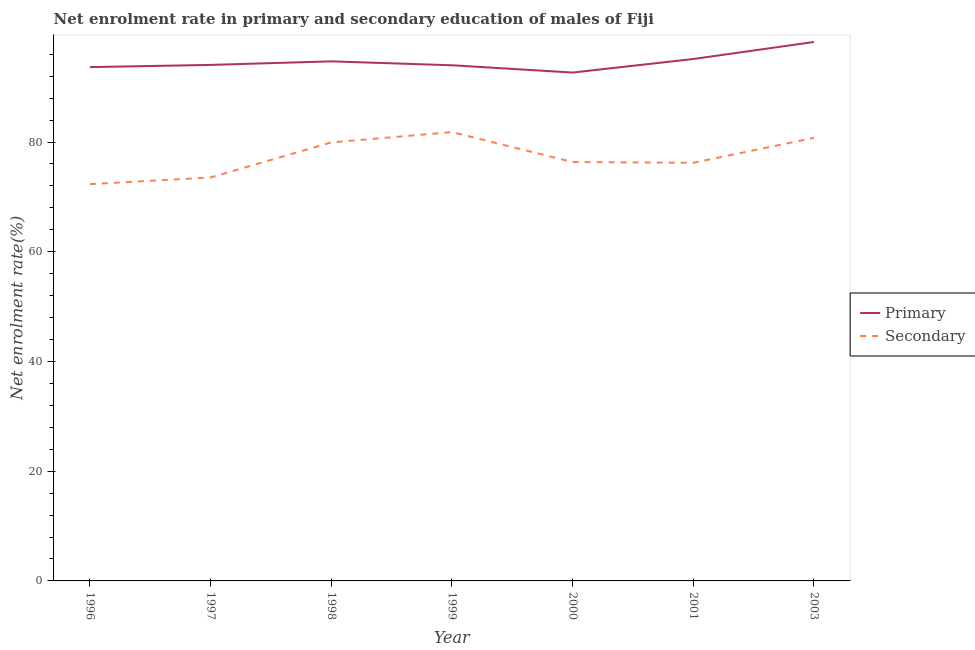Is the number of lines equal to the number of legend labels?
Keep it short and to the point. Yes. What is the enrollment rate in primary education in 2000?
Keep it short and to the point. 92.66. Across all years, what is the maximum enrollment rate in primary education?
Give a very brief answer. 98.23. Across all years, what is the minimum enrollment rate in secondary education?
Ensure brevity in your answer.  72.32. In which year was the enrollment rate in primary education maximum?
Give a very brief answer. 2003. What is the total enrollment rate in primary education in the graph?
Your response must be concise. 662.42. What is the difference between the enrollment rate in primary education in 1999 and that in 2000?
Keep it short and to the point. 1.33. What is the difference between the enrollment rate in secondary education in 1999 and the enrollment rate in primary education in 1996?
Keep it short and to the point. -11.85. What is the average enrollment rate in secondary education per year?
Ensure brevity in your answer.  77.27. In the year 1998, what is the difference between the enrollment rate in secondary education and enrollment rate in primary education?
Give a very brief answer. -14.77. In how many years, is the enrollment rate in secondary education greater than 52 %?
Give a very brief answer. 7. What is the ratio of the enrollment rate in secondary education in 1996 to that in 1999?
Your answer should be compact. 0.88. What is the difference between the highest and the second highest enrollment rate in secondary education?
Your response must be concise. 1.04. What is the difference between the highest and the lowest enrollment rate in primary education?
Offer a very short reply. 5.57. In how many years, is the enrollment rate in secondary education greater than the average enrollment rate in secondary education taken over all years?
Provide a short and direct response. 3. Is the enrollment rate in primary education strictly less than the enrollment rate in secondary education over the years?
Ensure brevity in your answer.  No. How many lines are there?
Offer a terse response. 2. Does the graph contain any zero values?
Ensure brevity in your answer.  No. Does the graph contain grids?
Keep it short and to the point. No. How many legend labels are there?
Your response must be concise. 2. What is the title of the graph?
Your answer should be very brief. Net enrolment rate in primary and secondary education of males of Fiji. What is the label or title of the X-axis?
Provide a succinct answer. Year. What is the label or title of the Y-axis?
Provide a short and direct response. Net enrolment rate(%). What is the Net enrolment rate(%) in Primary in 1996?
Offer a very short reply. 93.65. What is the Net enrolment rate(%) in Secondary in 1996?
Offer a terse response. 72.32. What is the Net enrolment rate(%) in Primary in 1997?
Your response must be concise. 94.05. What is the Net enrolment rate(%) of Secondary in 1997?
Give a very brief answer. 73.54. What is the Net enrolment rate(%) in Primary in 1998?
Your answer should be very brief. 94.7. What is the Net enrolment rate(%) of Secondary in 1998?
Provide a short and direct response. 79.93. What is the Net enrolment rate(%) of Primary in 1999?
Provide a succinct answer. 93.99. What is the Net enrolment rate(%) of Secondary in 1999?
Provide a succinct answer. 81.81. What is the Net enrolment rate(%) in Primary in 2000?
Your answer should be compact. 92.66. What is the Net enrolment rate(%) in Secondary in 2000?
Your answer should be very brief. 76.35. What is the Net enrolment rate(%) of Primary in 2001?
Offer a terse response. 95.13. What is the Net enrolment rate(%) in Secondary in 2001?
Your answer should be compact. 76.21. What is the Net enrolment rate(%) of Primary in 2003?
Give a very brief answer. 98.23. What is the Net enrolment rate(%) in Secondary in 2003?
Make the answer very short. 80.76. Across all years, what is the maximum Net enrolment rate(%) of Primary?
Your response must be concise. 98.23. Across all years, what is the maximum Net enrolment rate(%) of Secondary?
Offer a terse response. 81.81. Across all years, what is the minimum Net enrolment rate(%) of Primary?
Your answer should be very brief. 92.66. Across all years, what is the minimum Net enrolment rate(%) in Secondary?
Your response must be concise. 72.32. What is the total Net enrolment rate(%) in Primary in the graph?
Provide a short and direct response. 662.42. What is the total Net enrolment rate(%) in Secondary in the graph?
Ensure brevity in your answer.  540.92. What is the difference between the Net enrolment rate(%) of Primary in 1996 and that in 1997?
Provide a short and direct response. -0.4. What is the difference between the Net enrolment rate(%) of Secondary in 1996 and that in 1997?
Your answer should be compact. -1.21. What is the difference between the Net enrolment rate(%) of Primary in 1996 and that in 1998?
Your answer should be very brief. -1.05. What is the difference between the Net enrolment rate(%) in Secondary in 1996 and that in 1998?
Ensure brevity in your answer.  -7.61. What is the difference between the Net enrolment rate(%) of Primary in 1996 and that in 1999?
Your answer should be very brief. -0.34. What is the difference between the Net enrolment rate(%) in Secondary in 1996 and that in 1999?
Offer a very short reply. -9.49. What is the difference between the Net enrolment rate(%) in Primary in 1996 and that in 2000?
Provide a succinct answer. 0.99. What is the difference between the Net enrolment rate(%) of Secondary in 1996 and that in 2000?
Offer a terse response. -4.03. What is the difference between the Net enrolment rate(%) of Primary in 1996 and that in 2001?
Offer a terse response. -1.48. What is the difference between the Net enrolment rate(%) in Secondary in 1996 and that in 2001?
Provide a short and direct response. -3.89. What is the difference between the Net enrolment rate(%) in Primary in 1996 and that in 2003?
Ensure brevity in your answer.  -4.58. What is the difference between the Net enrolment rate(%) in Secondary in 1996 and that in 2003?
Your answer should be compact. -8.44. What is the difference between the Net enrolment rate(%) in Primary in 1997 and that in 1998?
Provide a succinct answer. -0.65. What is the difference between the Net enrolment rate(%) of Secondary in 1997 and that in 1998?
Ensure brevity in your answer.  -6.4. What is the difference between the Net enrolment rate(%) in Primary in 1997 and that in 1999?
Your answer should be very brief. 0.07. What is the difference between the Net enrolment rate(%) of Secondary in 1997 and that in 1999?
Make the answer very short. -8.27. What is the difference between the Net enrolment rate(%) in Primary in 1997 and that in 2000?
Offer a terse response. 1.39. What is the difference between the Net enrolment rate(%) in Secondary in 1997 and that in 2000?
Your answer should be compact. -2.82. What is the difference between the Net enrolment rate(%) in Primary in 1997 and that in 2001?
Your response must be concise. -1.07. What is the difference between the Net enrolment rate(%) in Secondary in 1997 and that in 2001?
Provide a succinct answer. -2.67. What is the difference between the Net enrolment rate(%) of Primary in 1997 and that in 2003?
Give a very brief answer. -4.18. What is the difference between the Net enrolment rate(%) in Secondary in 1997 and that in 2003?
Give a very brief answer. -7.23. What is the difference between the Net enrolment rate(%) of Primary in 1998 and that in 1999?
Your answer should be very brief. 0.71. What is the difference between the Net enrolment rate(%) of Secondary in 1998 and that in 1999?
Ensure brevity in your answer.  -1.87. What is the difference between the Net enrolment rate(%) of Primary in 1998 and that in 2000?
Provide a short and direct response. 2.04. What is the difference between the Net enrolment rate(%) of Secondary in 1998 and that in 2000?
Provide a succinct answer. 3.58. What is the difference between the Net enrolment rate(%) in Primary in 1998 and that in 2001?
Provide a succinct answer. -0.43. What is the difference between the Net enrolment rate(%) of Secondary in 1998 and that in 2001?
Your answer should be compact. 3.72. What is the difference between the Net enrolment rate(%) in Primary in 1998 and that in 2003?
Ensure brevity in your answer.  -3.53. What is the difference between the Net enrolment rate(%) of Secondary in 1998 and that in 2003?
Your answer should be compact. -0.83. What is the difference between the Net enrolment rate(%) in Primary in 1999 and that in 2000?
Keep it short and to the point. 1.33. What is the difference between the Net enrolment rate(%) in Secondary in 1999 and that in 2000?
Ensure brevity in your answer.  5.46. What is the difference between the Net enrolment rate(%) in Primary in 1999 and that in 2001?
Keep it short and to the point. -1.14. What is the difference between the Net enrolment rate(%) in Secondary in 1999 and that in 2001?
Your answer should be very brief. 5.6. What is the difference between the Net enrolment rate(%) in Primary in 1999 and that in 2003?
Your answer should be compact. -4.24. What is the difference between the Net enrolment rate(%) in Secondary in 1999 and that in 2003?
Ensure brevity in your answer.  1.04. What is the difference between the Net enrolment rate(%) in Primary in 2000 and that in 2001?
Offer a very short reply. -2.47. What is the difference between the Net enrolment rate(%) of Secondary in 2000 and that in 2001?
Ensure brevity in your answer.  0.14. What is the difference between the Net enrolment rate(%) of Primary in 2000 and that in 2003?
Your response must be concise. -5.57. What is the difference between the Net enrolment rate(%) in Secondary in 2000 and that in 2003?
Ensure brevity in your answer.  -4.41. What is the difference between the Net enrolment rate(%) of Primary in 2001 and that in 2003?
Your answer should be very brief. -3.1. What is the difference between the Net enrolment rate(%) of Secondary in 2001 and that in 2003?
Offer a terse response. -4.56. What is the difference between the Net enrolment rate(%) of Primary in 1996 and the Net enrolment rate(%) of Secondary in 1997?
Provide a short and direct response. 20.12. What is the difference between the Net enrolment rate(%) in Primary in 1996 and the Net enrolment rate(%) in Secondary in 1998?
Offer a very short reply. 13.72. What is the difference between the Net enrolment rate(%) of Primary in 1996 and the Net enrolment rate(%) of Secondary in 1999?
Offer a terse response. 11.85. What is the difference between the Net enrolment rate(%) of Primary in 1996 and the Net enrolment rate(%) of Secondary in 2000?
Offer a terse response. 17.3. What is the difference between the Net enrolment rate(%) of Primary in 1996 and the Net enrolment rate(%) of Secondary in 2001?
Ensure brevity in your answer.  17.45. What is the difference between the Net enrolment rate(%) in Primary in 1996 and the Net enrolment rate(%) in Secondary in 2003?
Keep it short and to the point. 12.89. What is the difference between the Net enrolment rate(%) in Primary in 1997 and the Net enrolment rate(%) in Secondary in 1998?
Your answer should be compact. 14.12. What is the difference between the Net enrolment rate(%) in Primary in 1997 and the Net enrolment rate(%) in Secondary in 1999?
Your response must be concise. 12.25. What is the difference between the Net enrolment rate(%) in Primary in 1997 and the Net enrolment rate(%) in Secondary in 2000?
Your answer should be very brief. 17.7. What is the difference between the Net enrolment rate(%) in Primary in 1997 and the Net enrolment rate(%) in Secondary in 2001?
Your response must be concise. 17.85. What is the difference between the Net enrolment rate(%) of Primary in 1997 and the Net enrolment rate(%) of Secondary in 2003?
Your response must be concise. 13.29. What is the difference between the Net enrolment rate(%) of Primary in 1998 and the Net enrolment rate(%) of Secondary in 1999?
Give a very brief answer. 12.89. What is the difference between the Net enrolment rate(%) in Primary in 1998 and the Net enrolment rate(%) in Secondary in 2000?
Provide a succinct answer. 18.35. What is the difference between the Net enrolment rate(%) of Primary in 1998 and the Net enrolment rate(%) of Secondary in 2001?
Provide a short and direct response. 18.49. What is the difference between the Net enrolment rate(%) in Primary in 1998 and the Net enrolment rate(%) in Secondary in 2003?
Your response must be concise. 13.94. What is the difference between the Net enrolment rate(%) of Primary in 1999 and the Net enrolment rate(%) of Secondary in 2000?
Offer a very short reply. 17.64. What is the difference between the Net enrolment rate(%) in Primary in 1999 and the Net enrolment rate(%) in Secondary in 2001?
Offer a very short reply. 17.78. What is the difference between the Net enrolment rate(%) of Primary in 1999 and the Net enrolment rate(%) of Secondary in 2003?
Keep it short and to the point. 13.22. What is the difference between the Net enrolment rate(%) of Primary in 2000 and the Net enrolment rate(%) of Secondary in 2001?
Make the answer very short. 16.45. What is the difference between the Net enrolment rate(%) of Primary in 2000 and the Net enrolment rate(%) of Secondary in 2003?
Give a very brief answer. 11.9. What is the difference between the Net enrolment rate(%) in Primary in 2001 and the Net enrolment rate(%) in Secondary in 2003?
Your response must be concise. 14.36. What is the average Net enrolment rate(%) of Primary per year?
Your answer should be compact. 94.63. What is the average Net enrolment rate(%) of Secondary per year?
Your answer should be very brief. 77.27. In the year 1996, what is the difference between the Net enrolment rate(%) of Primary and Net enrolment rate(%) of Secondary?
Your answer should be very brief. 21.33. In the year 1997, what is the difference between the Net enrolment rate(%) of Primary and Net enrolment rate(%) of Secondary?
Make the answer very short. 20.52. In the year 1998, what is the difference between the Net enrolment rate(%) of Primary and Net enrolment rate(%) of Secondary?
Provide a short and direct response. 14.77. In the year 1999, what is the difference between the Net enrolment rate(%) in Primary and Net enrolment rate(%) in Secondary?
Ensure brevity in your answer.  12.18. In the year 2000, what is the difference between the Net enrolment rate(%) in Primary and Net enrolment rate(%) in Secondary?
Your response must be concise. 16.31. In the year 2001, what is the difference between the Net enrolment rate(%) in Primary and Net enrolment rate(%) in Secondary?
Provide a succinct answer. 18.92. In the year 2003, what is the difference between the Net enrolment rate(%) in Primary and Net enrolment rate(%) in Secondary?
Your answer should be very brief. 17.47. What is the ratio of the Net enrolment rate(%) of Secondary in 1996 to that in 1997?
Keep it short and to the point. 0.98. What is the ratio of the Net enrolment rate(%) in Primary in 1996 to that in 1998?
Ensure brevity in your answer.  0.99. What is the ratio of the Net enrolment rate(%) in Secondary in 1996 to that in 1998?
Offer a very short reply. 0.9. What is the ratio of the Net enrolment rate(%) of Secondary in 1996 to that in 1999?
Offer a terse response. 0.88. What is the ratio of the Net enrolment rate(%) of Primary in 1996 to that in 2000?
Offer a very short reply. 1.01. What is the ratio of the Net enrolment rate(%) of Secondary in 1996 to that in 2000?
Provide a short and direct response. 0.95. What is the ratio of the Net enrolment rate(%) in Primary in 1996 to that in 2001?
Offer a very short reply. 0.98. What is the ratio of the Net enrolment rate(%) of Secondary in 1996 to that in 2001?
Provide a short and direct response. 0.95. What is the ratio of the Net enrolment rate(%) of Primary in 1996 to that in 2003?
Make the answer very short. 0.95. What is the ratio of the Net enrolment rate(%) of Secondary in 1996 to that in 2003?
Provide a succinct answer. 0.9. What is the ratio of the Net enrolment rate(%) in Secondary in 1997 to that in 1998?
Your answer should be very brief. 0.92. What is the ratio of the Net enrolment rate(%) in Primary in 1997 to that in 1999?
Give a very brief answer. 1. What is the ratio of the Net enrolment rate(%) in Secondary in 1997 to that in 1999?
Offer a very short reply. 0.9. What is the ratio of the Net enrolment rate(%) in Primary in 1997 to that in 2000?
Offer a very short reply. 1.01. What is the ratio of the Net enrolment rate(%) of Secondary in 1997 to that in 2000?
Keep it short and to the point. 0.96. What is the ratio of the Net enrolment rate(%) in Primary in 1997 to that in 2001?
Provide a succinct answer. 0.99. What is the ratio of the Net enrolment rate(%) of Secondary in 1997 to that in 2001?
Keep it short and to the point. 0.96. What is the ratio of the Net enrolment rate(%) of Primary in 1997 to that in 2003?
Offer a very short reply. 0.96. What is the ratio of the Net enrolment rate(%) of Secondary in 1997 to that in 2003?
Provide a short and direct response. 0.91. What is the ratio of the Net enrolment rate(%) of Primary in 1998 to that in 1999?
Ensure brevity in your answer.  1.01. What is the ratio of the Net enrolment rate(%) in Secondary in 1998 to that in 1999?
Provide a succinct answer. 0.98. What is the ratio of the Net enrolment rate(%) of Secondary in 1998 to that in 2000?
Offer a terse response. 1.05. What is the ratio of the Net enrolment rate(%) of Primary in 1998 to that in 2001?
Your response must be concise. 1. What is the ratio of the Net enrolment rate(%) in Secondary in 1998 to that in 2001?
Offer a very short reply. 1.05. What is the ratio of the Net enrolment rate(%) of Secondary in 1998 to that in 2003?
Offer a terse response. 0.99. What is the ratio of the Net enrolment rate(%) of Primary in 1999 to that in 2000?
Offer a terse response. 1.01. What is the ratio of the Net enrolment rate(%) in Secondary in 1999 to that in 2000?
Give a very brief answer. 1.07. What is the ratio of the Net enrolment rate(%) in Secondary in 1999 to that in 2001?
Keep it short and to the point. 1.07. What is the ratio of the Net enrolment rate(%) of Primary in 1999 to that in 2003?
Ensure brevity in your answer.  0.96. What is the ratio of the Net enrolment rate(%) of Secondary in 1999 to that in 2003?
Ensure brevity in your answer.  1.01. What is the ratio of the Net enrolment rate(%) in Primary in 2000 to that in 2001?
Your answer should be very brief. 0.97. What is the ratio of the Net enrolment rate(%) of Secondary in 2000 to that in 2001?
Your response must be concise. 1. What is the ratio of the Net enrolment rate(%) of Primary in 2000 to that in 2003?
Your response must be concise. 0.94. What is the ratio of the Net enrolment rate(%) of Secondary in 2000 to that in 2003?
Ensure brevity in your answer.  0.95. What is the ratio of the Net enrolment rate(%) in Primary in 2001 to that in 2003?
Your response must be concise. 0.97. What is the ratio of the Net enrolment rate(%) of Secondary in 2001 to that in 2003?
Provide a short and direct response. 0.94. What is the difference between the highest and the second highest Net enrolment rate(%) of Primary?
Provide a short and direct response. 3.1. What is the difference between the highest and the second highest Net enrolment rate(%) of Secondary?
Your response must be concise. 1.04. What is the difference between the highest and the lowest Net enrolment rate(%) of Primary?
Your answer should be compact. 5.57. What is the difference between the highest and the lowest Net enrolment rate(%) in Secondary?
Provide a succinct answer. 9.49. 